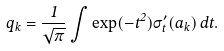Convert formula to latex. <formula><loc_0><loc_0><loc_500><loc_500>q _ { k } = \frac { 1 } { \sqrt { \pi } } \int \exp ( - t ^ { 2 } ) \sigma ^ { \prime } _ { t } ( a _ { k } ) \, d t .</formula> 